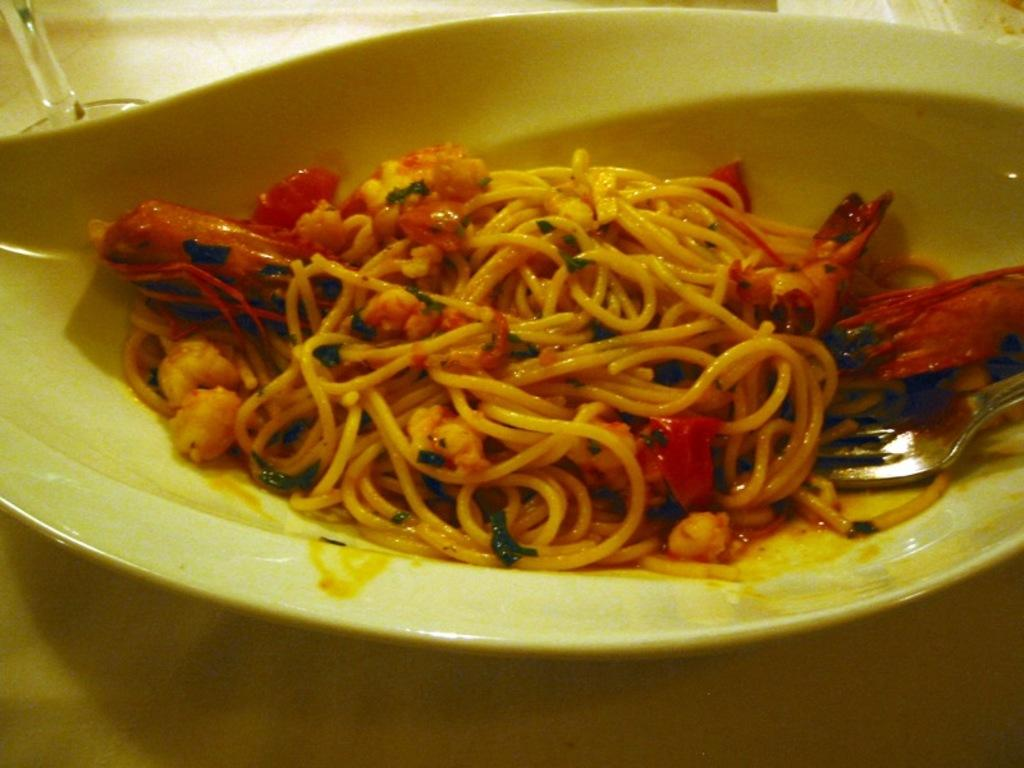What is present on the plate in the image? There is food on the plate in the image. What utensil is visible in the image? There is a fork in the image. Can you describe the surface on which the plate and fork are placed? The food, plate, and fork are placed on a platform in the image. What type of pleasure does the minister's aunt experience while looking at the image? There is no reference to a minister or an aunt in the image, so it is not possible to determine what type of pleasure they might experience. 